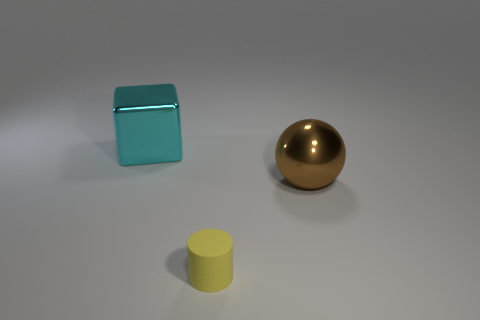Add 2 small yellow objects. How many objects exist? 5 Subtract all cylinders. How many objects are left? 2 Subtract 0 gray cubes. How many objects are left? 3 Subtract all blue objects. Subtract all balls. How many objects are left? 2 Add 1 metallic things. How many metallic things are left? 3 Add 1 big purple rubber things. How many big purple rubber things exist? 1 